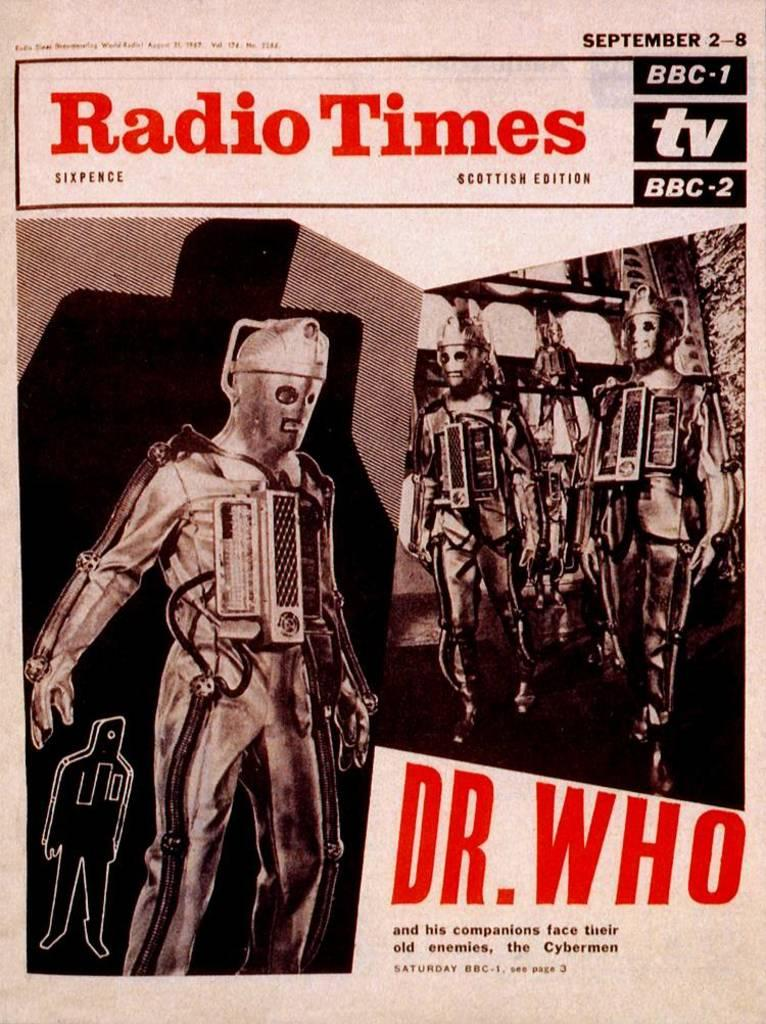<image>
Create a compact narrative representing the image presented. An article from September from the Radio Times on Dr. Who. 